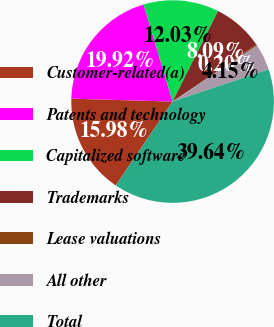Convert chart to OTSL. <chart><loc_0><loc_0><loc_500><loc_500><pie_chart><fcel>Customer-related(a)<fcel>Patents and technology<fcel>Capitalized software<fcel>Trademarks<fcel>Lease valuations<fcel>All other<fcel>Total<nl><fcel>15.98%<fcel>19.92%<fcel>12.03%<fcel>8.09%<fcel>0.2%<fcel>4.15%<fcel>39.64%<nl></chart> 